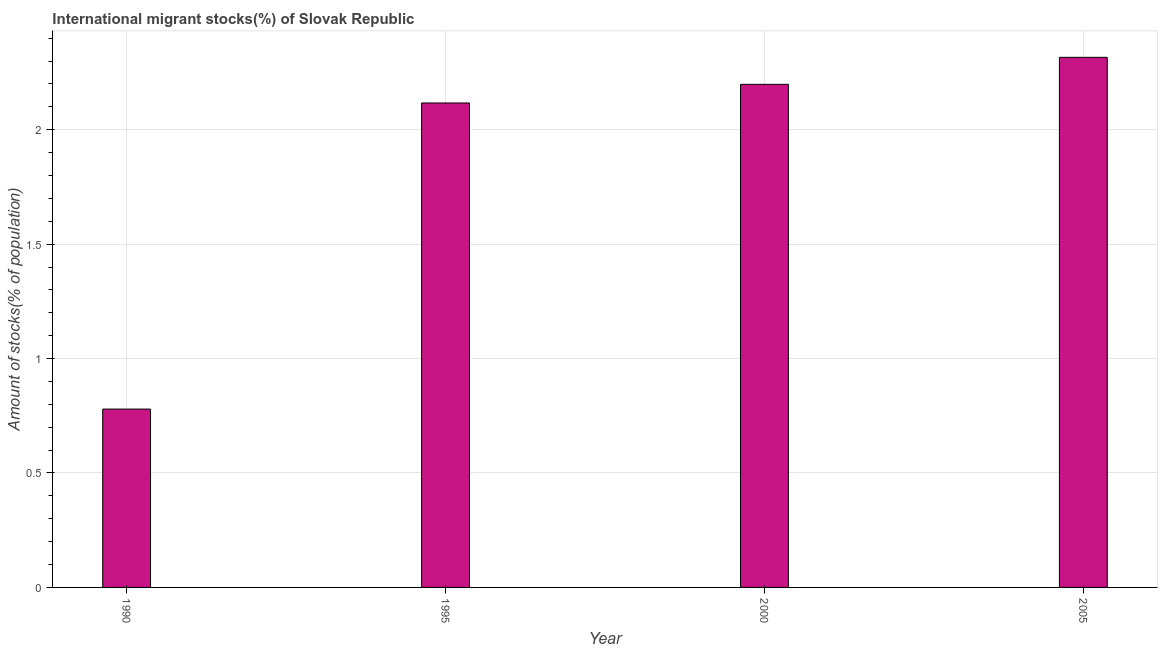Does the graph contain grids?
Make the answer very short. Yes. What is the title of the graph?
Make the answer very short. International migrant stocks(%) of Slovak Republic. What is the label or title of the Y-axis?
Make the answer very short. Amount of stocks(% of population). What is the number of international migrant stocks in 2000?
Your answer should be compact. 2.2. Across all years, what is the maximum number of international migrant stocks?
Offer a very short reply. 2.32. Across all years, what is the minimum number of international migrant stocks?
Provide a succinct answer. 0.78. In which year was the number of international migrant stocks maximum?
Offer a terse response. 2005. In which year was the number of international migrant stocks minimum?
Provide a short and direct response. 1990. What is the sum of the number of international migrant stocks?
Keep it short and to the point. 7.41. What is the difference between the number of international migrant stocks in 1995 and 2005?
Your answer should be compact. -0.2. What is the average number of international migrant stocks per year?
Provide a short and direct response. 1.85. What is the median number of international migrant stocks?
Provide a short and direct response. 2.16. Do a majority of the years between 1990 and 2005 (inclusive) have number of international migrant stocks greater than 1.3 %?
Keep it short and to the point. Yes. What is the ratio of the number of international migrant stocks in 2000 to that in 2005?
Your response must be concise. 0.95. Is the number of international migrant stocks in 1990 less than that in 2005?
Your response must be concise. Yes. Is the difference between the number of international migrant stocks in 2000 and 2005 greater than the difference between any two years?
Your answer should be very brief. No. What is the difference between the highest and the second highest number of international migrant stocks?
Offer a very short reply. 0.12. What is the difference between the highest and the lowest number of international migrant stocks?
Provide a short and direct response. 1.54. How many bars are there?
Offer a terse response. 4. Are all the bars in the graph horizontal?
Your answer should be very brief. No. How many years are there in the graph?
Offer a terse response. 4. Are the values on the major ticks of Y-axis written in scientific E-notation?
Your answer should be very brief. No. What is the Amount of stocks(% of population) of 1990?
Make the answer very short. 0.78. What is the Amount of stocks(% of population) in 1995?
Ensure brevity in your answer.  2.12. What is the Amount of stocks(% of population) in 2000?
Give a very brief answer. 2.2. What is the Amount of stocks(% of population) of 2005?
Keep it short and to the point. 2.32. What is the difference between the Amount of stocks(% of population) in 1990 and 1995?
Keep it short and to the point. -1.34. What is the difference between the Amount of stocks(% of population) in 1990 and 2000?
Provide a succinct answer. -1.42. What is the difference between the Amount of stocks(% of population) in 1990 and 2005?
Keep it short and to the point. -1.54. What is the difference between the Amount of stocks(% of population) in 1995 and 2000?
Offer a terse response. -0.08. What is the difference between the Amount of stocks(% of population) in 1995 and 2005?
Keep it short and to the point. -0.2. What is the difference between the Amount of stocks(% of population) in 2000 and 2005?
Offer a terse response. -0.12. What is the ratio of the Amount of stocks(% of population) in 1990 to that in 1995?
Make the answer very short. 0.37. What is the ratio of the Amount of stocks(% of population) in 1990 to that in 2000?
Provide a short and direct response. 0.35. What is the ratio of the Amount of stocks(% of population) in 1990 to that in 2005?
Keep it short and to the point. 0.34. What is the ratio of the Amount of stocks(% of population) in 1995 to that in 2005?
Offer a very short reply. 0.91. What is the ratio of the Amount of stocks(% of population) in 2000 to that in 2005?
Make the answer very short. 0.95. 